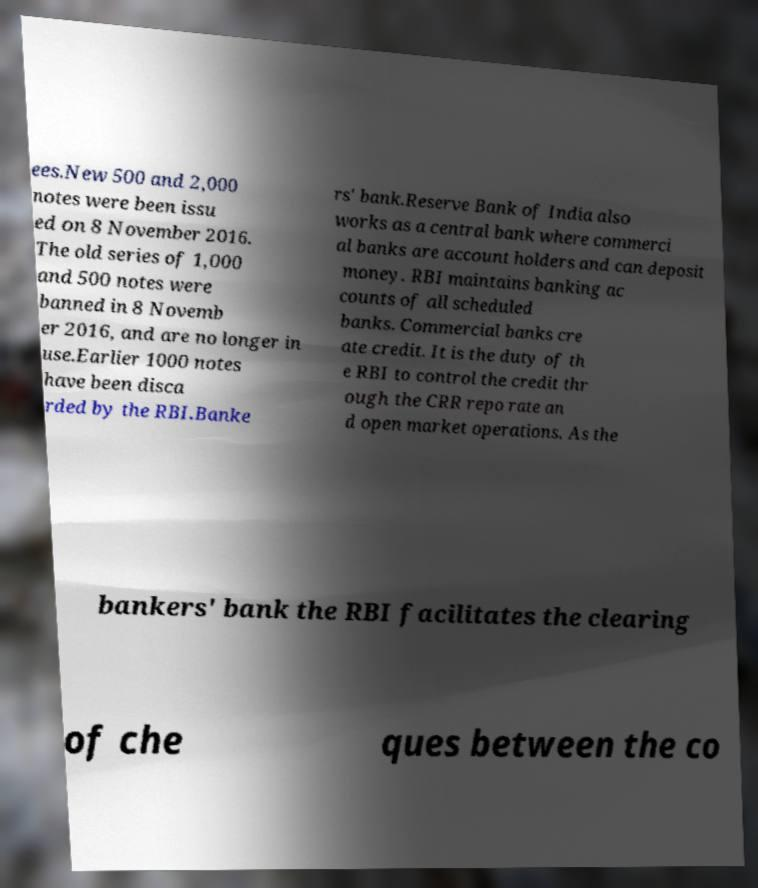What messages or text are displayed in this image? I need them in a readable, typed format. ees.New 500 and 2,000 notes were been issu ed on 8 November 2016. The old series of 1,000 and 500 notes were banned in 8 Novemb er 2016, and are no longer in use.Earlier 1000 notes have been disca rded by the RBI.Banke rs' bank.Reserve Bank of India also works as a central bank where commerci al banks are account holders and can deposit money. RBI maintains banking ac counts of all scheduled banks. Commercial banks cre ate credit. It is the duty of th e RBI to control the credit thr ough the CRR repo rate an d open market operations. As the bankers' bank the RBI facilitates the clearing of che ques between the co 